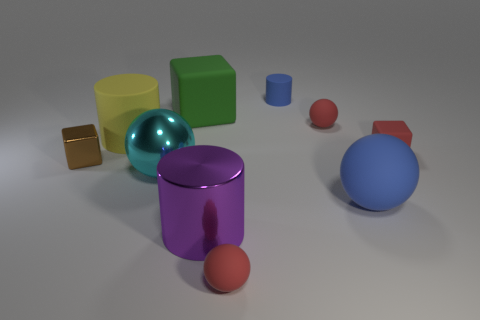What is the color of the object that is right of the large matte ball?
Provide a short and direct response. Red. What number of purple things are behind the rubber block that is behind the red ball that is on the right side of the small cylinder?
Your answer should be compact. 0. There is a block that is both to the left of the purple metal cylinder and on the right side of the brown shiny thing; what is it made of?
Your response must be concise. Rubber. Does the yellow object have the same material as the tiny block behind the tiny brown cube?
Offer a terse response. Yes. Are there more small metallic blocks on the left side of the tiny metallic block than green rubber blocks to the left of the large yellow object?
Give a very brief answer. No. What is the shape of the yellow rubber object?
Your answer should be compact. Cylinder. Is the large cylinder that is behind the large metal cylinder made of the same material as the small red sphere in front of the small brown shiny cube?
Provide a succinct answer. Yes. The big object that is in front of the large blue object has what shape?
Give a very brief answer. Cylinder. There is a brown shiny thing that is the same shape as the large green matte thing; what size is it?
Make the answer very short. Small. Do the metallic cube and the shiny sphere have the same color?
Offer a terse response. No. 